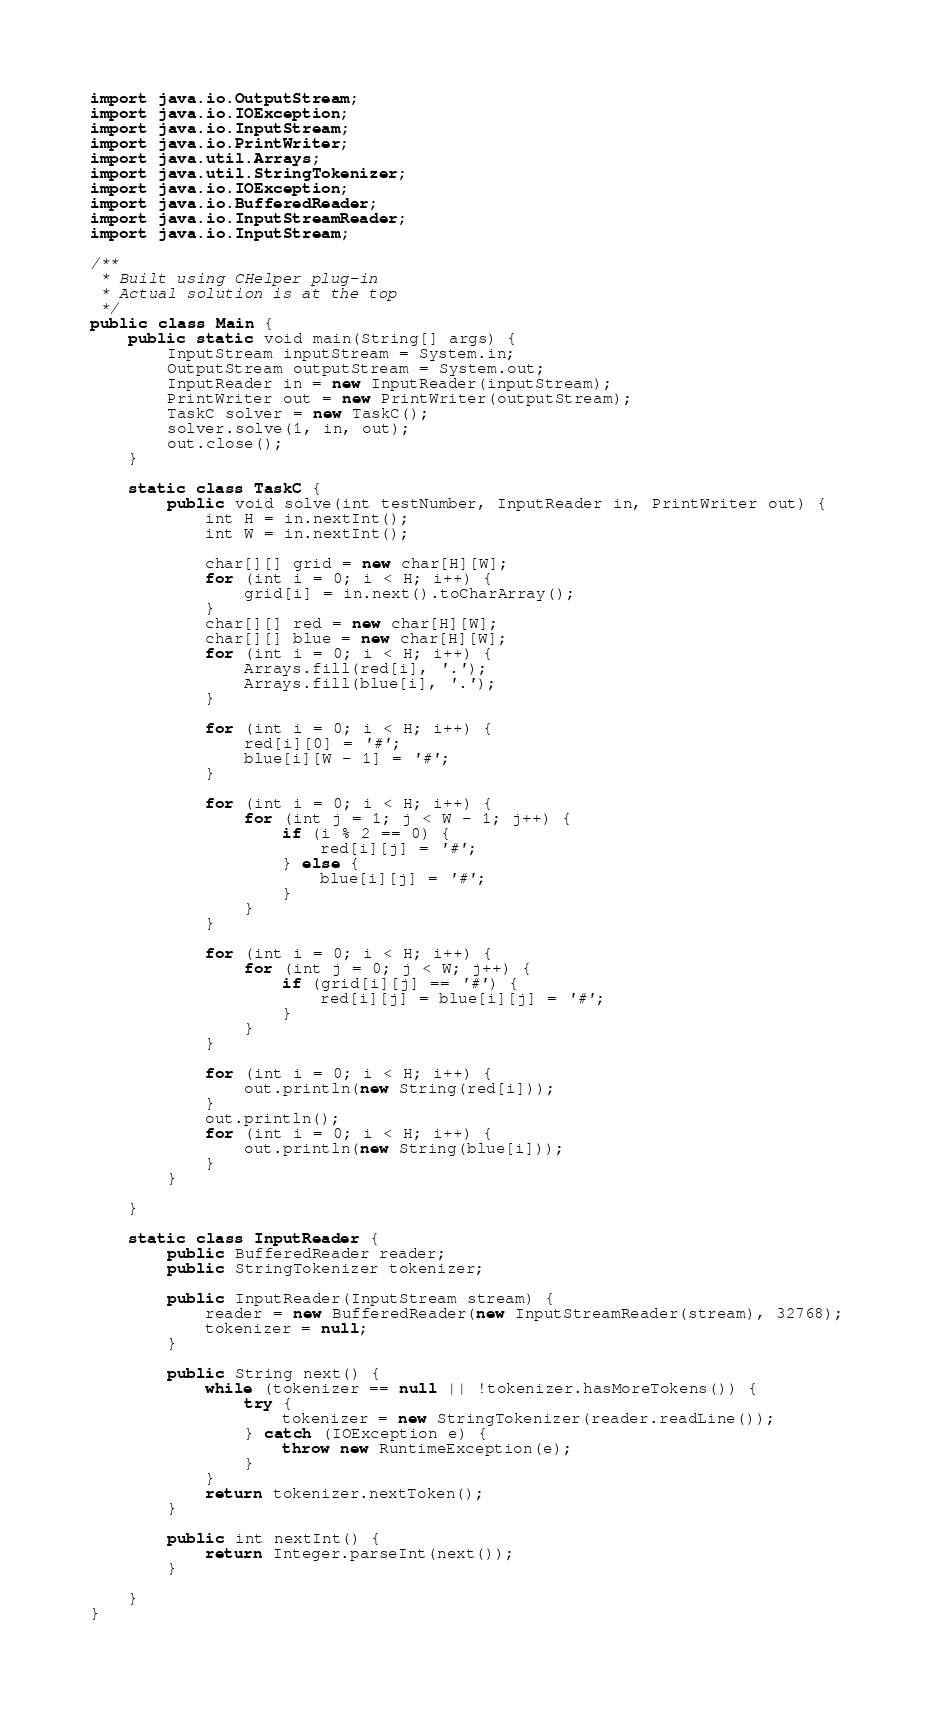<code> <loc_0><loc_0><loc_500><loc_500><_Java_>import java.io.OutputStream;
import java.io.IOException;
import java.io.InputStream;
import java.io.PrintWriter;
import java.util.Arrays;
import java.util.StringTokenizer;
import java.io.IOException;
import java.io.BufferedReader;
import java.io.InputStreamReader;
import java.io.InputStream;

/**
 * Built using CHelper plug-in
 * Actual solution is at the top
 */
public class Main {
    public static void main(String[] args) {
        InputStream inputStream = System.in;
        OutputStream outputStream = System.out;
        InputReader in = new InputReader(inputStream);
        PrintWriter out = new PrintWriter(outputStream);
        TaskC solver = new TaskC();
        solver.solve(1, in, out);
        out.close();
    }

    static class TaskC {
        public void solve(int testNumber, InputReader in, PrintWriter out) {
            int H = in.nextInt();
            int W = in.nextInt();

            char[][] grid = new char[H][W];
            for (int i = 0; i < H; i++) {
                grid[i] = in.next().toCharArray();
            }
            char[][] red = new char[H][W];
            char[][] blue = new char[H][W];
            for (int i = 0; i < H; i++) {
                Arrays.fill(red[i], '.');
                Arrays.fill(blue[i], '.');
            }

            for (int i = 0; i < H; i++) {
                red[i][0] = '#';
                blue[i][W - 1] = '#';
            }

            for (int i = 0; i < H; i++) {
                for (int j = 1; j < W - 1; j++) {
                    if (i % 2 == 0) {
                        red[i][j] = '#';
                    } else {
                        blue[i][j] = '#';
                    }
                }
            }

            for (int i = 0; i < H; i++) {
                for (int j = 0; j < W; j++) {
                    if (grid[i][j] == '#') {
                        red[i][j] = blue[i][j] = '#';
                    }
                }
            }

            for (int i = 0; i < H; i++) {
                out.println(new String(red[i]));
            }
            out.println();
            for (int i = 0; i < H; i++) {
                out.println(new String(blue[i]));
            }
        }

    }

    static class InputReader {
        public BufferedReader reader;
        public StringTokenizer tokenizer;

        public InputReader(InputStream stream) {
            reader = new BufferedReader(new InputStreamReader(stream), 32768);
            tokenizer = null;
        }

        public String next() {
            while (tokenizer == null || !tokenizer.hasMoreTokens()) {
                try {
                    tokenizer = new StringTokenizer(reader.readLine());
                } catch (IOException e) {
                    throw new RuntimeException(e);
                }
            }
            return tokenizer.nextToken();
        }

        public int nextInt() {
            return Integer.parseInt(next());
        }

    }
}
</code> 